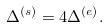Convert formula to latex. <formula><loc_0><loc_0><loc_500><loc_500>\Delta ^ { ( s ) } = 4 \Delta ^ { ( e ) } .</formula> 